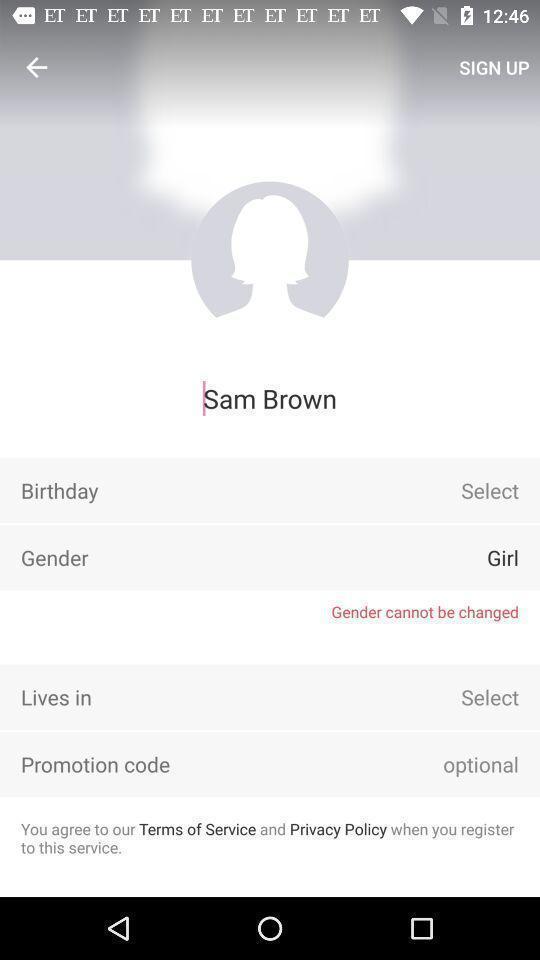What is the overall content of this screenshot? Screen showing the profile details. 